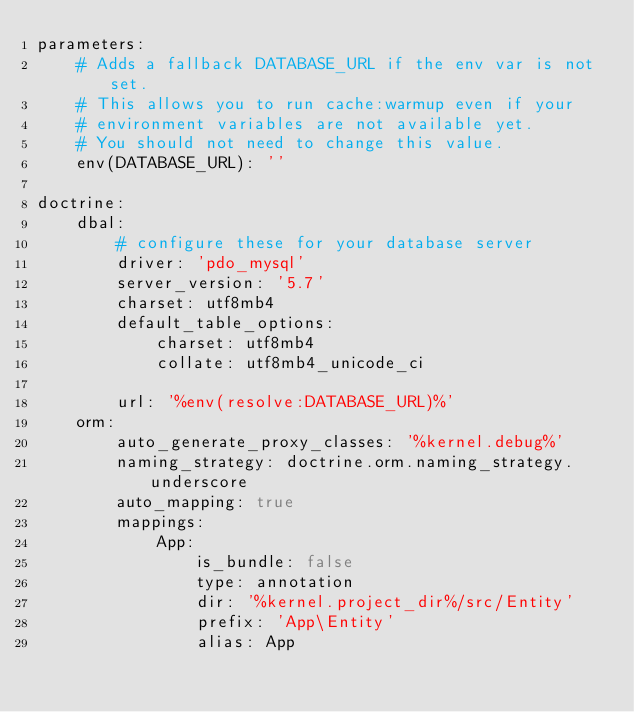Convert code to text. <code><loc_0><loc_0><loc_500><loc_500><_YAML_>parameters:
    # Adds a fallback DATABASE_URL if the env var is not set.
    # This allows you to run cache:warmup even if your
    # environment variables are not available yet.
    # You should not need to change this value.
    env(DATABASE_URL): ''

doctrine:
    dbal:
        # configure these for your database server
        driver: 'pdo_mysql'
        server_version: '5.7'
        charset: utf8mb4
        default_table_options:
            charset: utf8mb4
            collate: utf8mb4_unicode_ci

        url: '%env(resolve:DATABASE_URL)%'
    orm:
        auto_generate_proxy_classes: '%kernel.debug%'
        naming_strategy: doctrine.orm.naming_strategy.underscore
        auto_mapping: true
        mappings:
            App:
                is_bundle: false
                type: annotation
                dir: '%kernel.project_dir%/src/Entity'
                prefix: 'App\Entity'
                alias: App</code> 